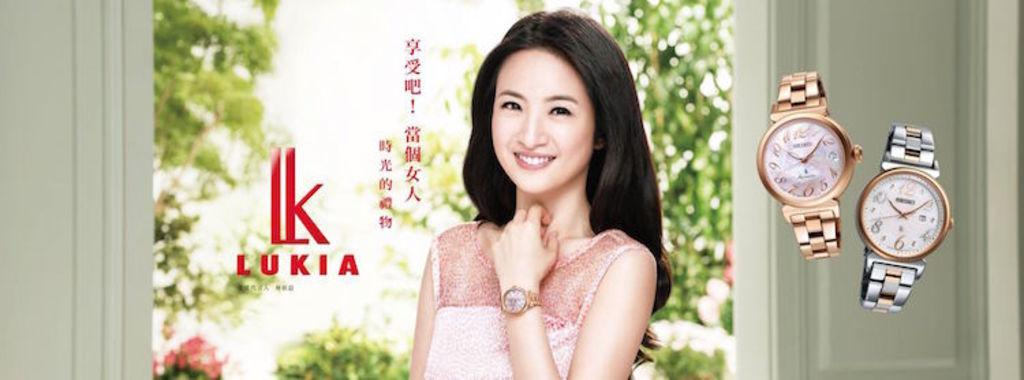Provide a one-sentence caption for the provided image. A pretty model wearing a watch with 2 other watches by Lukia. 